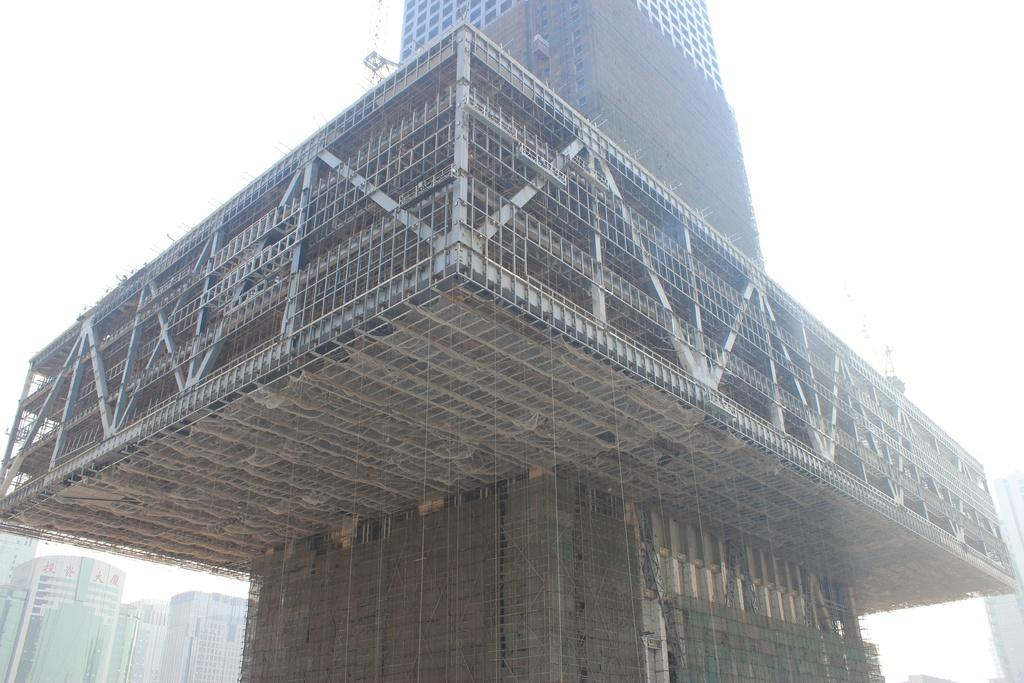What is the main subject in the middle of the image? There is a building in the middle of the image. Can you describe the surroundings of the main subject? There are buildings in the background of the image. What can be seen in the sky in the background of the image? The sky is visible in the background of the image. What type of property exchange is taking place between the farmers in the image? There are no farmers or property exchange present in the image; it features a building and other buildings in the background. 